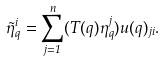<formula> <loc_0><loc_0><loc_500><loc_500>\tilde { \eta } _ { q } ^ { i } = \sum _ { j = 1 } ^ { n } ( T ( q ) \eta _ { q } ^ { j } ) u ( q ) _ { j i } .</formula> 